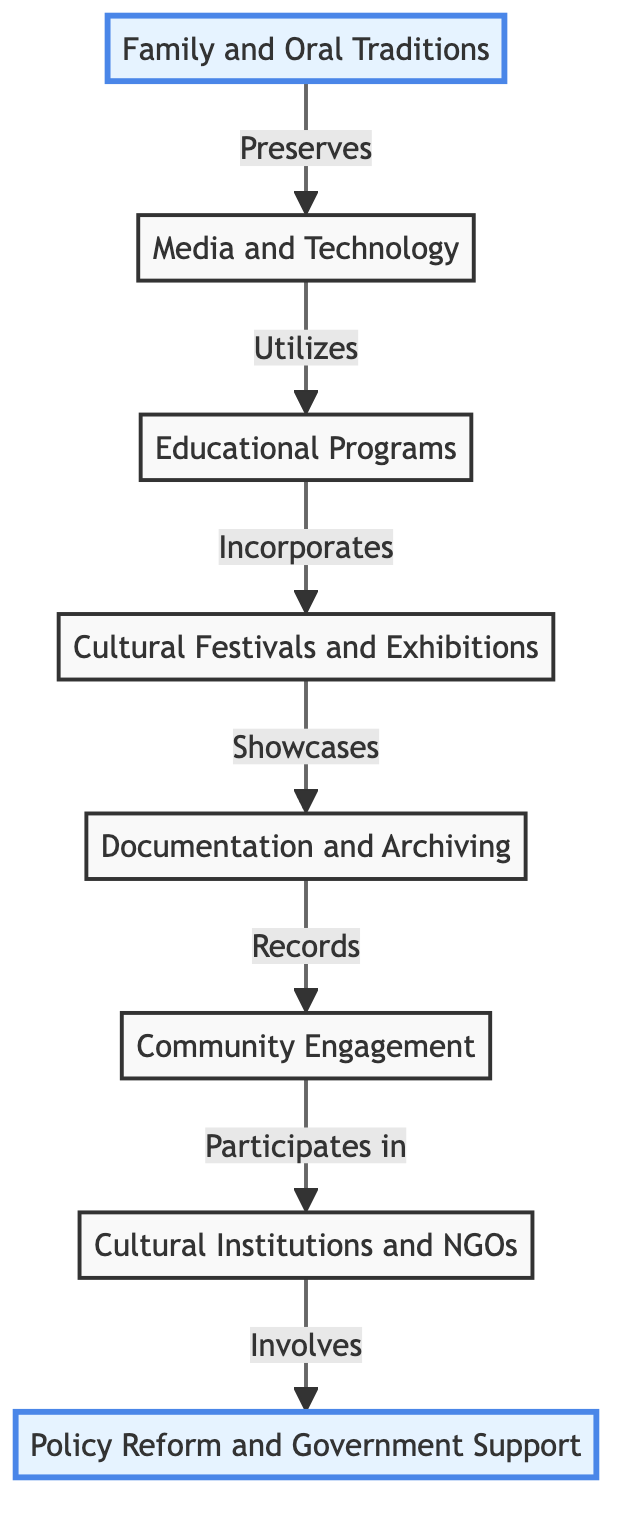What is the top node in the diagram? The top node is "Policy Reform and Government Support," which indicates the starting point for the flow of cultural preservation efforts in the diagram.
Answer: Policy Reform and Government Support How many nodes are there in the diagram? Counting the elements in the diagram, there are eight distinct nodes representing various stages of cultural preservation efforts.
Answer: 8 What is the relationship between "Cultural Institutions and NGOs" and "Community Engagement"? "Cultural Institutions and NGOs" involves the participation of museums and organizations that work to enhance "Community Engagement" in cultural preservation initiatives.
Answer: Involves Which node comes immediately before "Documentation and Archiving"? The node that comes immediately before "Documentation and Archiving" is "Community Engagement," indicating that effective archiving relies on community involvement.
Answer: Community Engagement What node follows "Educational Programs"? The node that follows "Educational Programs" is "Media and Technology," showing the progression from education to technology in cultural preservation.
Answer: Media and Technology What actions are showcased in "Cultural Festivals and Exhibitions"? "Cultural Festivals and Exhibitions" showcases traditional Syrian music, dance, crafts, and cuisine, presenting a variety of cultural elements to the public.
Answer: Showcases Which two nodes are highlighted in the diagram? The highlighted nodes in the diagram are "Family and Oral Traditions" at the bottom and "Policy Reform and Government Support" at the top, indicating their importance within the context of cultural preservation.
Answer: Family and Oral Traditions, Policy Reform and Government Support What occurs after "Documentation and Archiving"? After "Documentation and Archiving," the next step in the flow is "Cultural Festivals and Exhibitions," emphasizing the importance of sharing cultural heritage.
Answer: Cultural Festivals and Exhibitions Which node emphasizes the role of local communities? The node "Community Engagement" emphasizes the role of local communities in participating and contributing to cultural preservation initiatives.
Answer: Community Engagement 